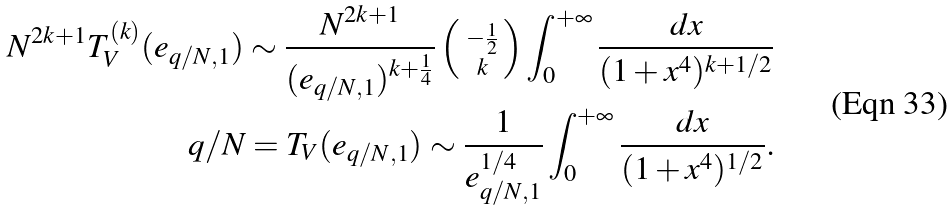Convert formula to latex. <formula><loc_0><loc_0><loc_500><loc_500>N ^ { 2 k + 1 } T _ { V } ^ { ( k ) } ( e _ { q / N , 1 } ) \sim \frac { N ^ { 2 k + 1 } } { ( e _ { q / N , 1 } ) ^ { k + \frac { 1 } { 4 } } } \left ( \begin{smallmatrix} \, - \frac { 1 } { 2 } \\ \, k \end{smallmatrix} \right ) \int _ { 0 } ^ { + \infty } \frac { d x } { ( 1 + x ^ { 4 } ) ^ { k + 1 / 2 } } \\ { q } / { N } = T _ { V } ( e _ { q / N , 1 } ) \sim \frac { 1 } { e _ { q / N , 1 } ^ { { 1 } / { 4 } } } \int _ { 0 } ^ { + \infty } \frac { d x } { ( 1 + x ^ { 4 } ) ^ { 1 / 2 } } .</formula> 